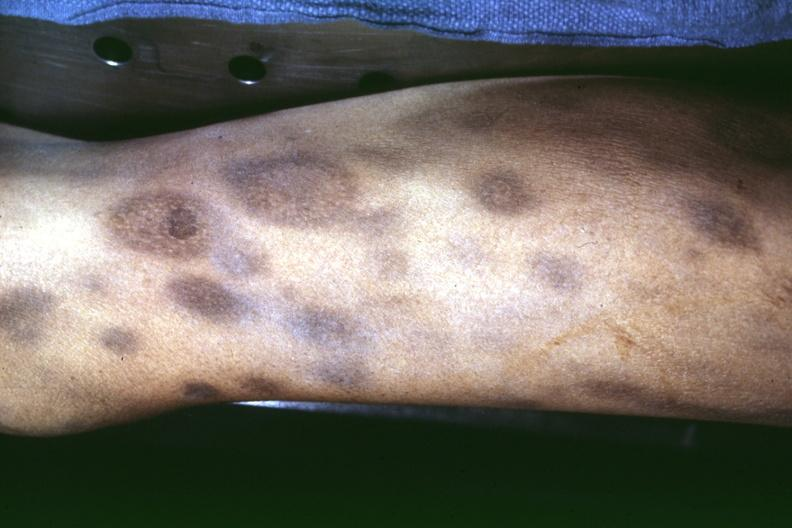what does necrotic appearing centers look?
Answer the question using a single word or phrase. Like pyoderma gangrenosum 